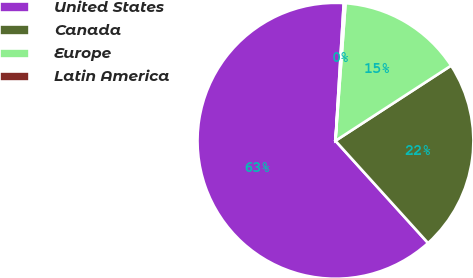Convert chart. <chart><loc_0><loc_0><loc_500><loc_500><pie_chart><fcel>United States<fcel>Canada<fcel>Europe<fcel>Latin America<nl><fcel>62.67%<fcel>22.46%<fcel>14.66%<fcel>0.21%<nl></chart> 